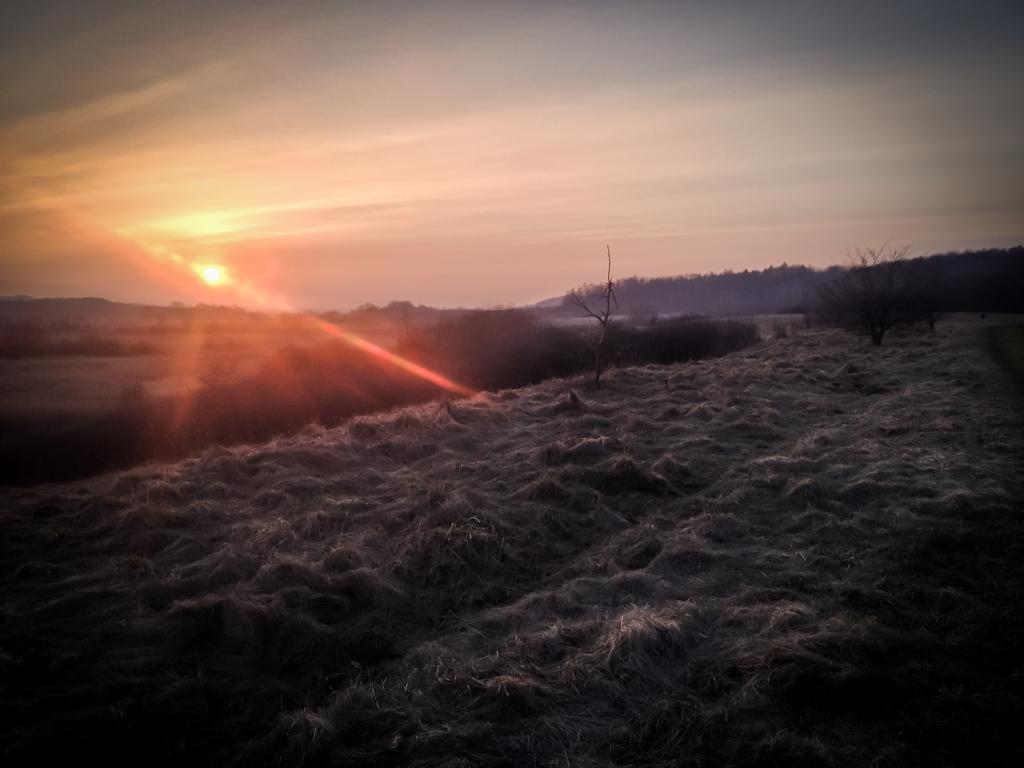What type of vegetation is present on the dry grass in the image? There are trees on the surface of the dry grass in the image. What geographical features can be seen in the background of the image? There are mountains in the background of the image. What part of the natural environment is visible in the image? The sky is visible in the background of the image. What decision does the tree make in the image? Trees do not make decisions, as they are inanimate objects. What question is being asked by the mountain in the image? Mountains do not ask questions, as they are inanimate objects. 